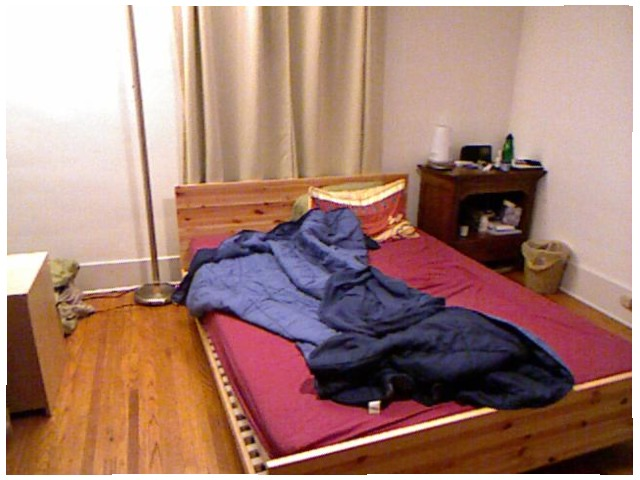<image>
Is the blanket on the pillow? Yes. Looking at the image, I can see the blanket is positioned on top of the pillow, with the pillow providing support. 